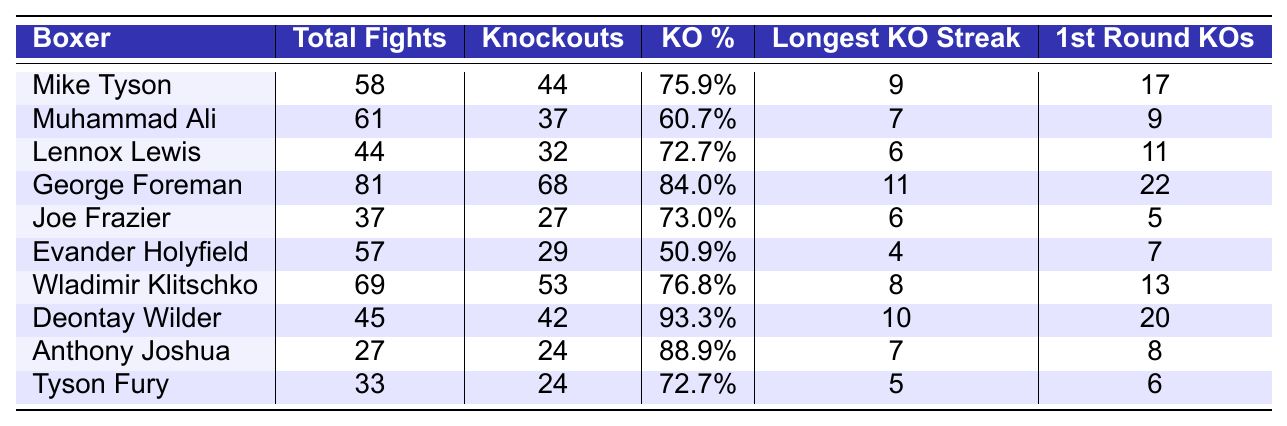What is the knockout percentage of Deontay Wilder? In the table, the knockout percentage for Deontay Wilder is provided in the "KO %" column. It shows 93.3%.
Answer: 93.3% Who has the longest KO streak among the boxers listed? The longest KO streak is found in the "Longest KO Streak" column. George Foreman has the longest streak at 11.
Answer: George Foreman How many total fights did Muhammad Ali have compared to Joe Frazier? The total fights for Muhammad Ali are 61, while Joe Frazier had 37 total fights. The difference is 61 - 37 = 24.
Answer: 24 Which boxer has the highest number of first-round KOs? By examining the "1st Round KOs" column, George Foreman has the highest number with 22 first-round KOs.
Answer: George Foreman What is the average knockout percentage of all the boxers listed? To find the average, sum the knockout percentages: (75.9 + 60.7 + 72.7 + 84.0 + 73.0 + 50.9 + 76.8 + 93.3 + 88.9 + 72.7) = 74.5% and divide by 10, which gives 74.5%.
Answer: 74.5% Is it true that Evander Holyfield had more knockouts than Joe Frazier? Evander Holyfield has 29 knockouts, while Joe Frazier has 27 knockouts. Since 29 > 27, the statement is true.
Answer: Yes Who is the only boxer with fewer total fights than Anthony Joshua? Looking at the table, Anthony Joshua has 27 total fights. The only boxer with fewer fights is Joe Frazier, with 37 total fights, thus there are no boxers with fewer.
Answer: None What is the difference in the number of knockouts between Wladimir Klitschko and Lennox Lewis? The number of knockouts for Wladimir Klitschko is 53 and for Lennox Lewis is 32. The difference is 53 - 32 = 21.
Answer: 21 Which boxers have a knockout percentage above 80%? Reviewing the "KO %" column, George Foreman (84.0%) and Deontay Wilder (93.3%) both have knockout percentages above 80%.
Answer: George Foreman, Deontay Wilder How many boxers in the table have a knockout percentage below 70%? By analyzing the "KO %" column, Evander Holyfield (50.9%) and Muhammad Ali (60.7%) both fall below 70%, making it 2 boxers.
Answer: 2 Who has the least number of first-round KOs among the boxers listed? The least number of first-round KOs can be found in the "1st Round KOs" column. Joe Frazier has the least with 5 first-round KOs.
Answer: Joe Frazier 